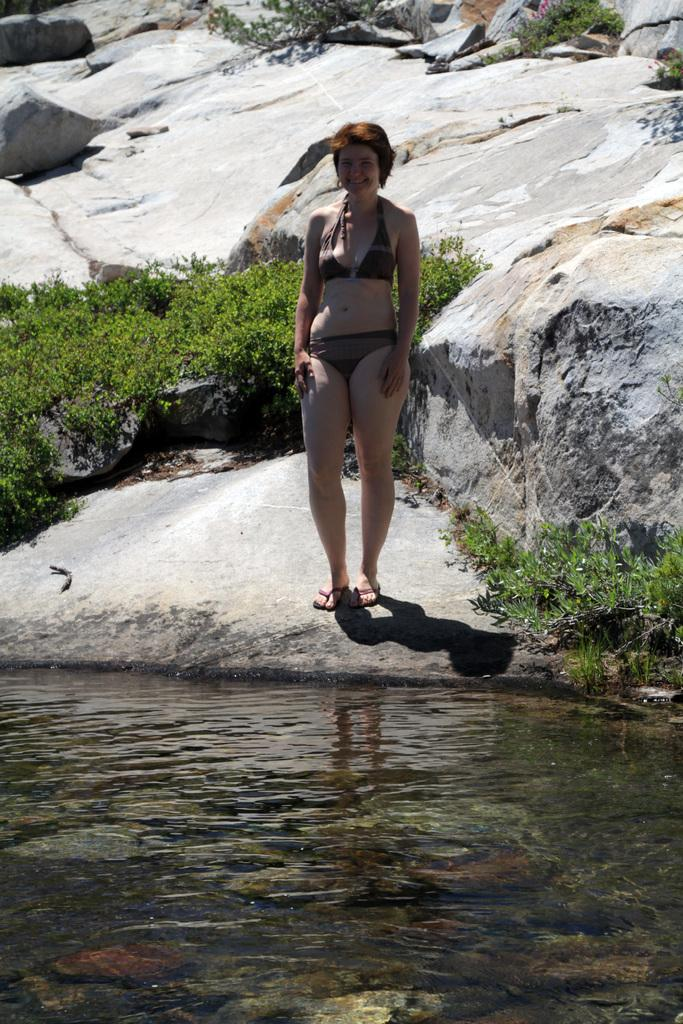Who is present in the image? There is a woman in the image. What is the woman standing on? The woman is standing on a rock. What is in front of the woman? There is water in front of the woman. What is behind the woman? There are plants and rocks behind the woman. What type of knife is the woman holding in the image? There is no knife present in the image; the woman is not holding anything. 